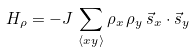<formula> <loc_0><loc_0><loc_500><loc_500>H _ { \rho } = - J \, \sum _ { \langle x y \rangle } \rho _ { x } \, \rho _ { y } \, \vec { s } _ { x } \cdot \vec { s } _ { y }</formula> 